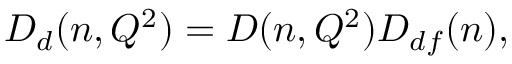<formula> <loc_0><loc_0><loc_500><loc_500>D _ { d } ( n , Q ^ { 2 } ) = D ( n , Q ^ { 2 } ) D _ { d f } ( n ) ,</formula> 